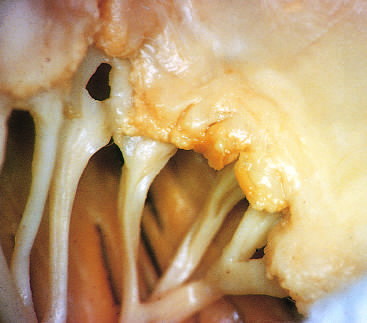re small vegetations visible along the line of closure of the mitral valve leaflets?
Answer the question using a single word or phrase. Yes 